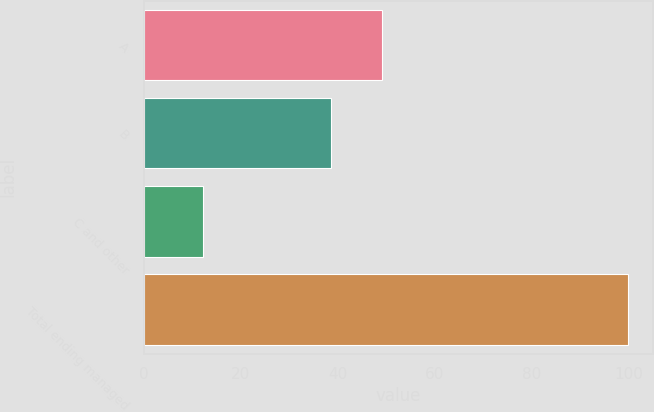Convert chart to OTSL. <chart><loc_0><loc_0><loc_500><loc_500><bar_chart><fcel>A<fcel>B<fcel>C and other<fcel>Total ending managed<nl><fcel>49.2<fcel>38.6<fcel>12.2<fcel>100<nl></chart> 